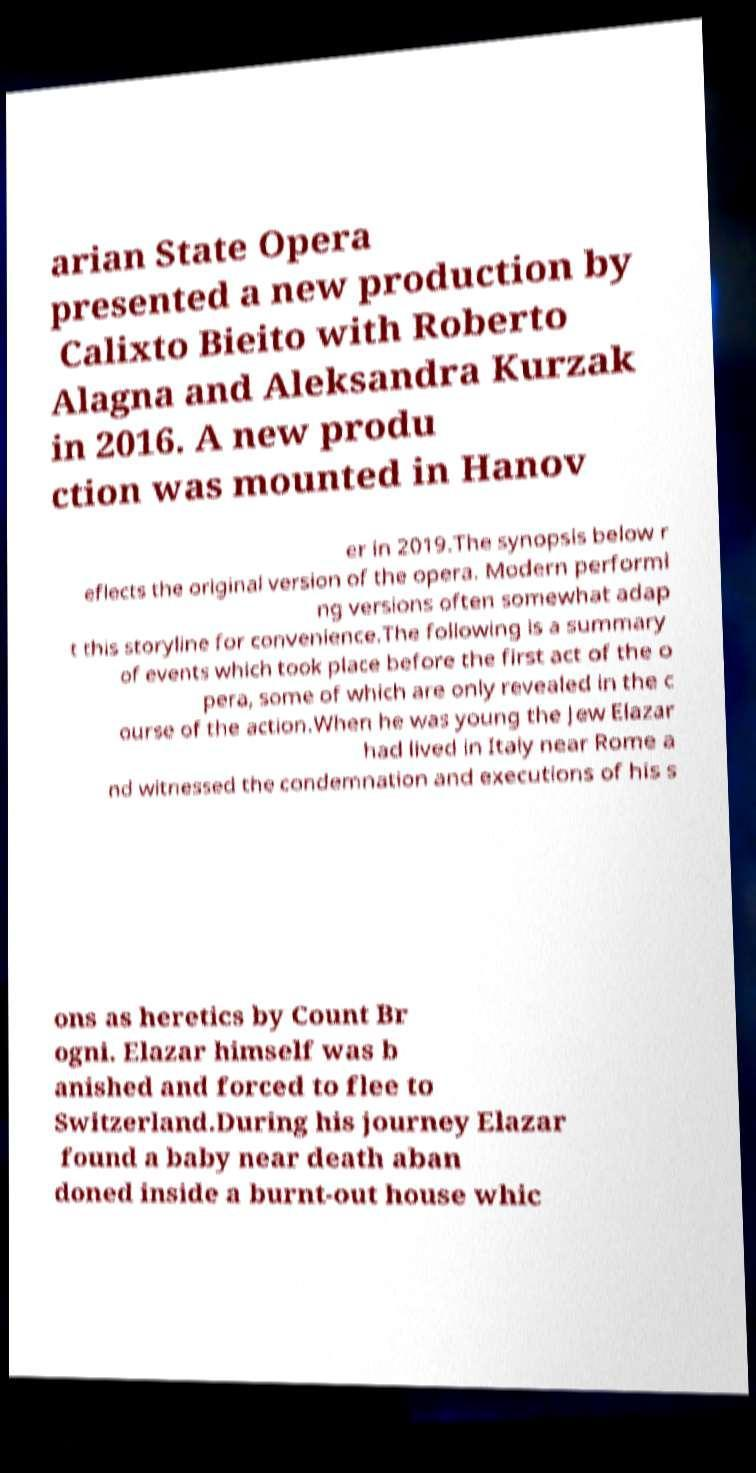For documentation purposes, I need the text within this image transcribed. Could you provide that? arian State Opera presented a new production by Calixto Bieito with Roberto Alagna and Aleksandra Kurzak in 2016. A new produ ction was mounted in Hanov er in 2019.The synopsis below r eflects the original version of the opera. Modern performi ng versions often somewhat adap t this storyline for convenience.The following is a summary of events which took place before the first act of the o pera, some of which are only revealed in the c ourse of the action.When he was young the Jew Elazar had lived in Italy near Rome a nd witnessed the condemnation and executions of his s ons as heretics by Count Br ogni. Elazar himself was b anished and forced to flee to Switzerland.During his journey Elazar found a baby near death aban doned inside a burnt-out house whic 